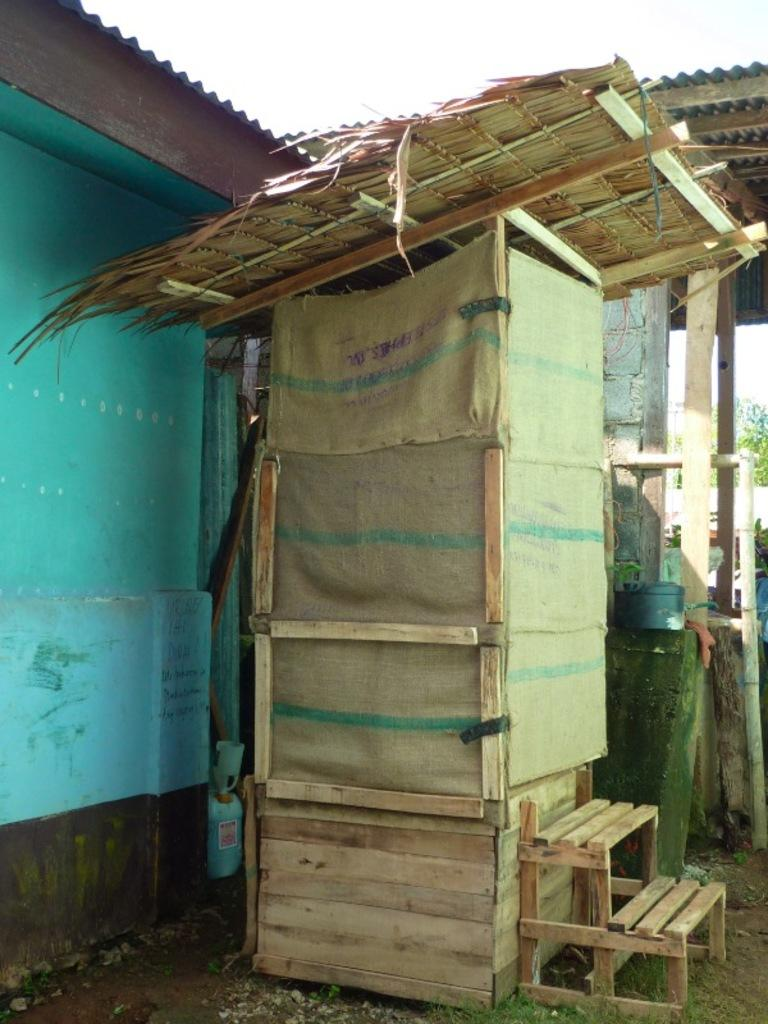What type of object is located in the front of the image? There is a wooden object in the front of the image. What structure can be seen on the left side of the image? There is a building on the left side of the image. What type of natural element is visible in the background of the image? There is a tree visible in the background of the image. What type of club is being used by the organization in the image? There is no club or organization present in the image; it only features a wooden object, a building, and a tree. What color is the pen used by the members of the organization in the image? There is no pen or organization present in the image. 